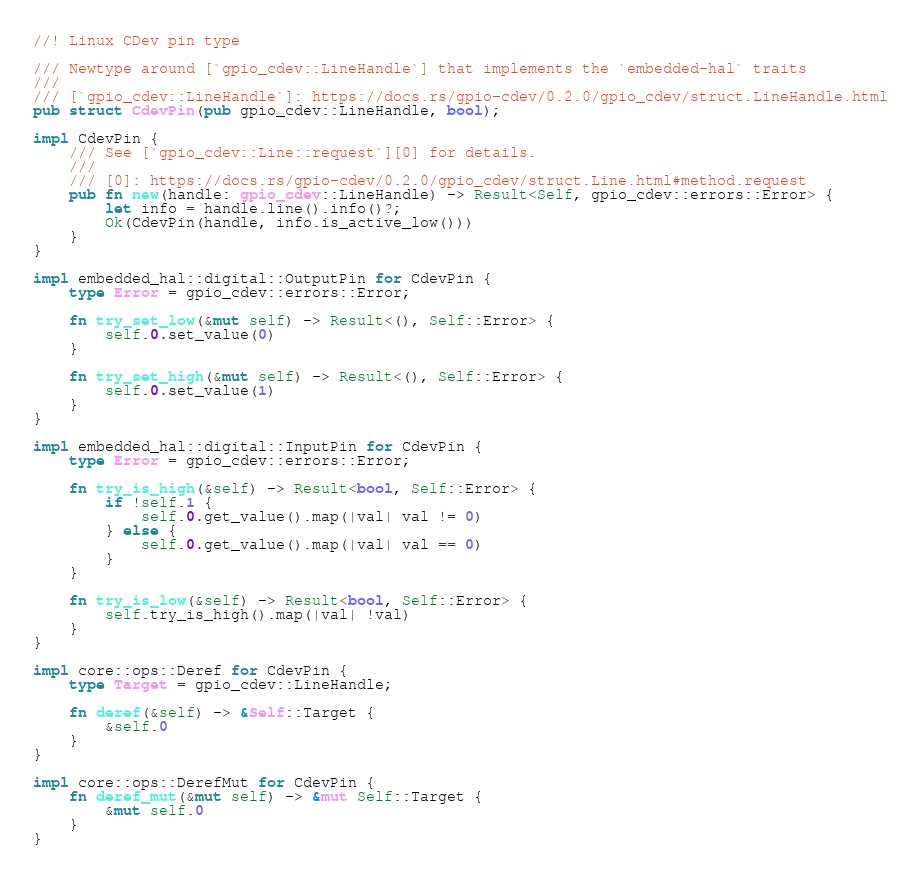<code> <loc_0><loc_0><loc_500><loc_500><_Rust_>//! Linux CDev pin type

/// Newtype around [`gpio_cdev::LineHandle`] that implements the `embedded-hal` traits
///
/// [`gpio_cdev::LineHandle`]: https://docs.rs/gpio-cdev/0.2.0/gpio_cdev/struct.LineHandle.html
pub struct CdevPin(pub gpio_cdev::LineHandle, bool);

impl CdevPin {
    /// See [`gpio_cdev::Line::request`][0] for details.
    ///
    /// [0]: https://docs.rs/gpio-cdev/0.2.0/gpio_cdev/struct.Line.html#method.request
    pub fn new(handle: gpio_cdev::LineHandle) -> Result<Self, gpio_cdev::errors::Error> {
        let info = handle.line().info()?;
        Ok(CdevPin(handle, info.is_active_low()))
    }
}

impl embedded_hal::digital::OutputPin for CdevPin {
    type Error = gpio_cdev::errors::Error;

    fn try_set_low(&mut self) -> Result<(), Self::Error> {
        self.0.set_value(0)
    }

    fn try_set_high(&mut self) -> Result<(), Self::Error> {
        self.0.set_value(1)
    }
}

impl embedded_hal::digital::InputPin for CdevPin {
    type Error = gpio_cdev::errors::Error;

    fn try_is_high(&self) -> Result<bool, Self::Error> {
        if !self.1 {
            self.0.get_value().map(|val| val != 0)
        } else {
            self.0.get_value().map(|val| val == 0)
        }
    }

    fn try_is_low(&self) -> Result<bool, Self::Error> {
        self.try_is_high().map(|val| !val)
    }
}

impl core::ops::Deref for CdevPin {
    type Target = gpio_cdev::LineHandle;

    fn deref(&self) -> &Self::Target {
        &self.0
    }
}

impl core::ops::DerefMut for CdevPin {
    fn deref_mut(&mut self) -> &mut Self::Target {
        &mut self.0
    }
}
</code> 